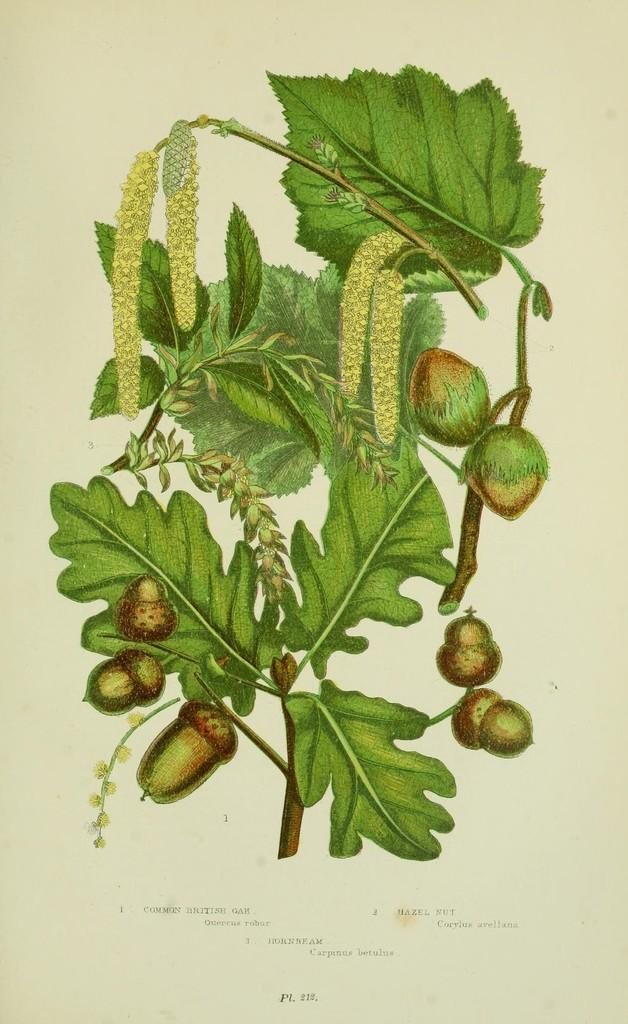What is the main subject of the drawing in the image? The main subject of the drawing in the image is a plant. Are there any other elements depicted along with the plant? Yes, there are fruits depicted on the paper. What else can be found on the paper besides the drawing of the plant and fruits? There are texts present on the paper. Can you see a snail jumping in the image? There is no snail or jumping depicted in the image; it features a drawing of a plant with fruits and texts. 